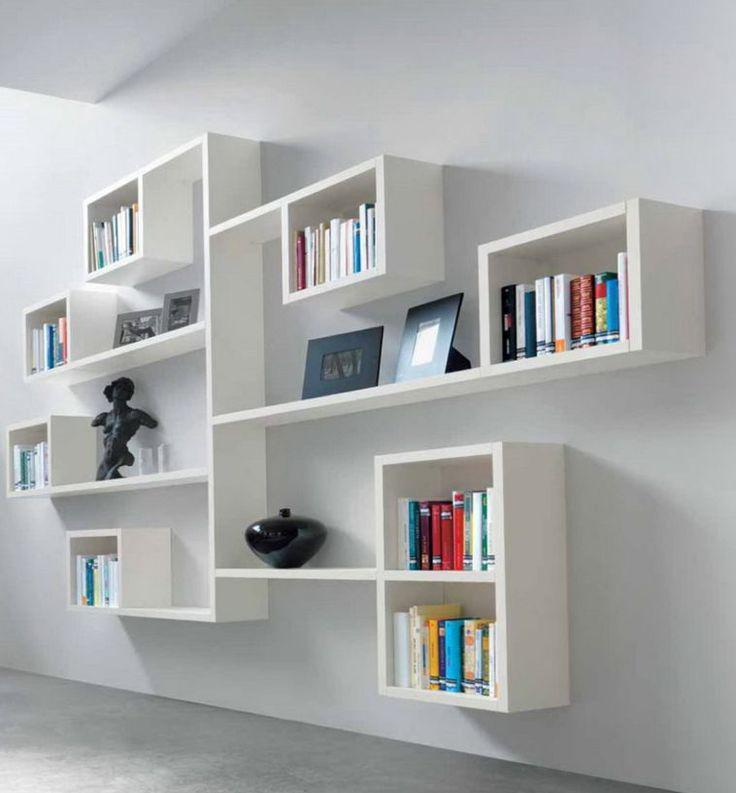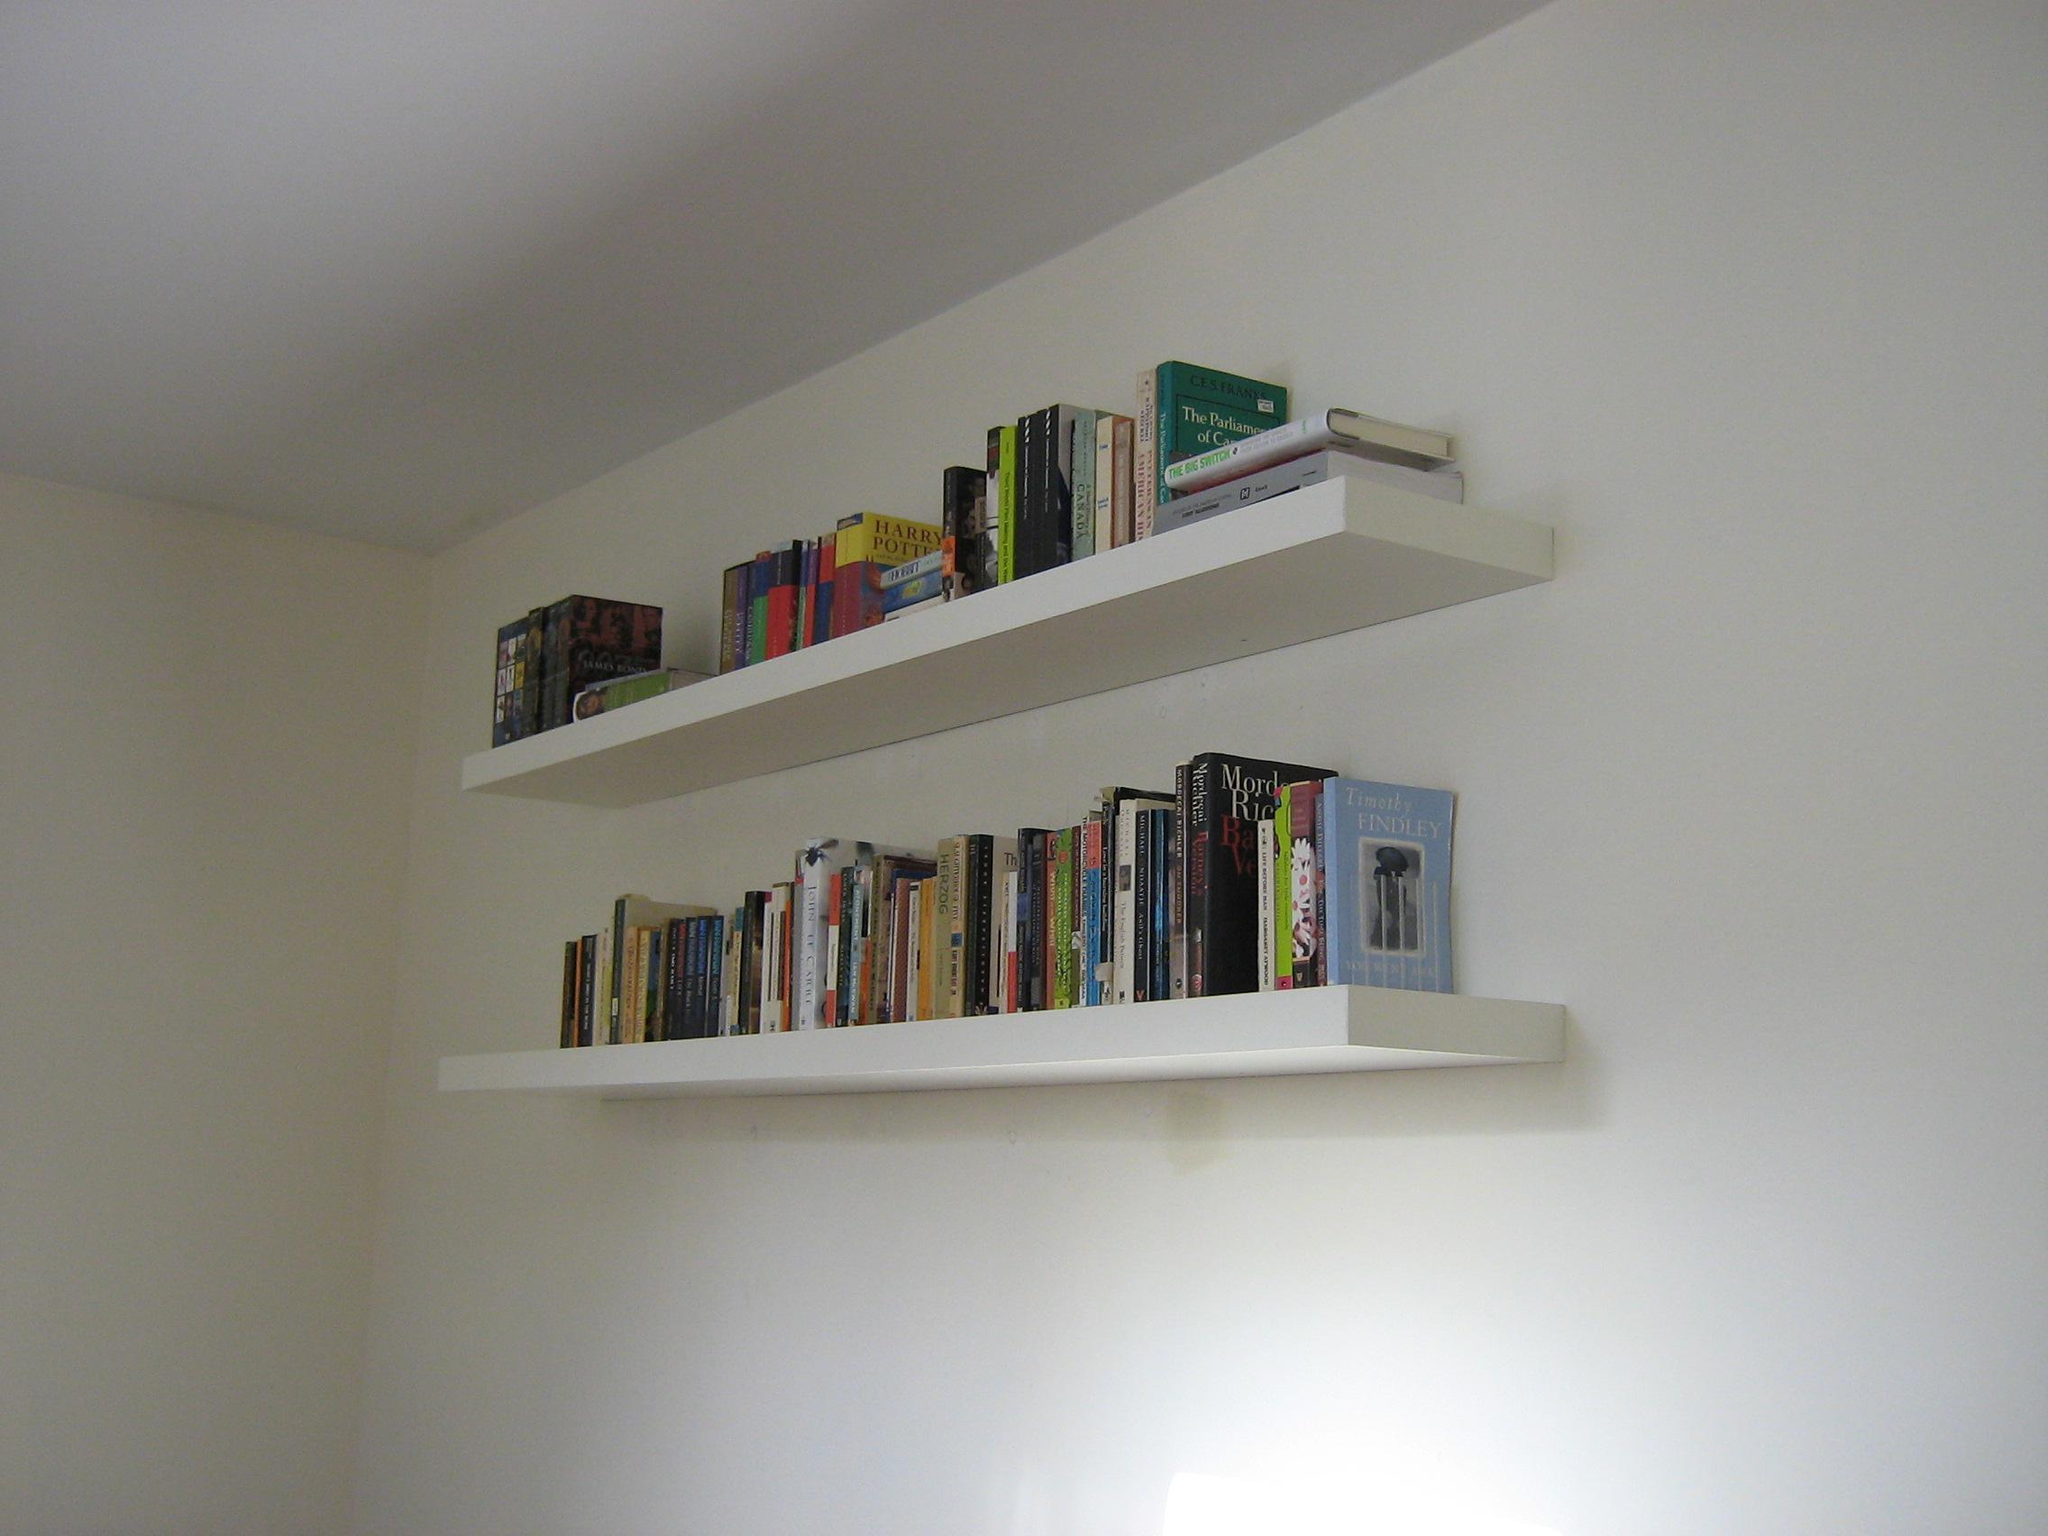The first image is the image on the left, the second image is the image on the right. Considering the images on both sides, is "There is at least one plant in the pair of images." valid? Answer yes or no. No. The first image is the image on the left, the second image is the image on the right. Analyze the images presented: Is the assertion "Both images show some type of floating white bookshelves that mount to the wall." valid? Answer yes or no. Yes. 